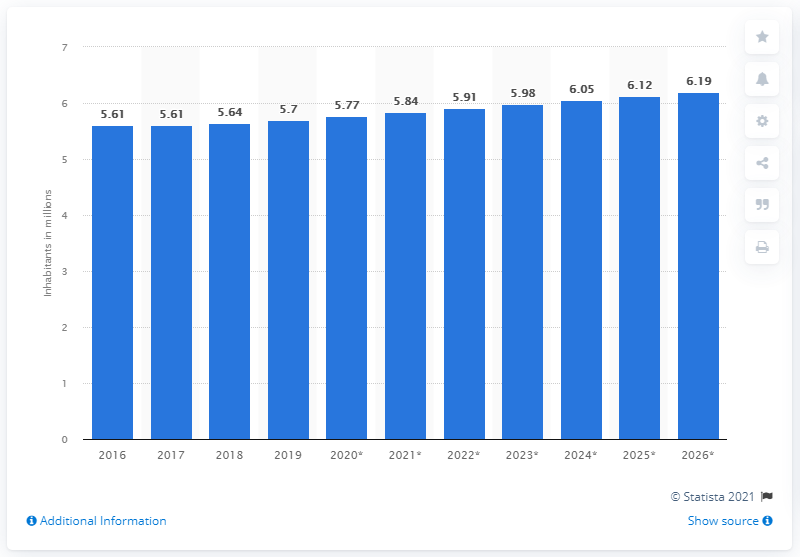Specify some key components in this picture. The population of Singapore in 2019 was approximately 5.7 million. Singapore's population decreased by 5.7% in the same year. 